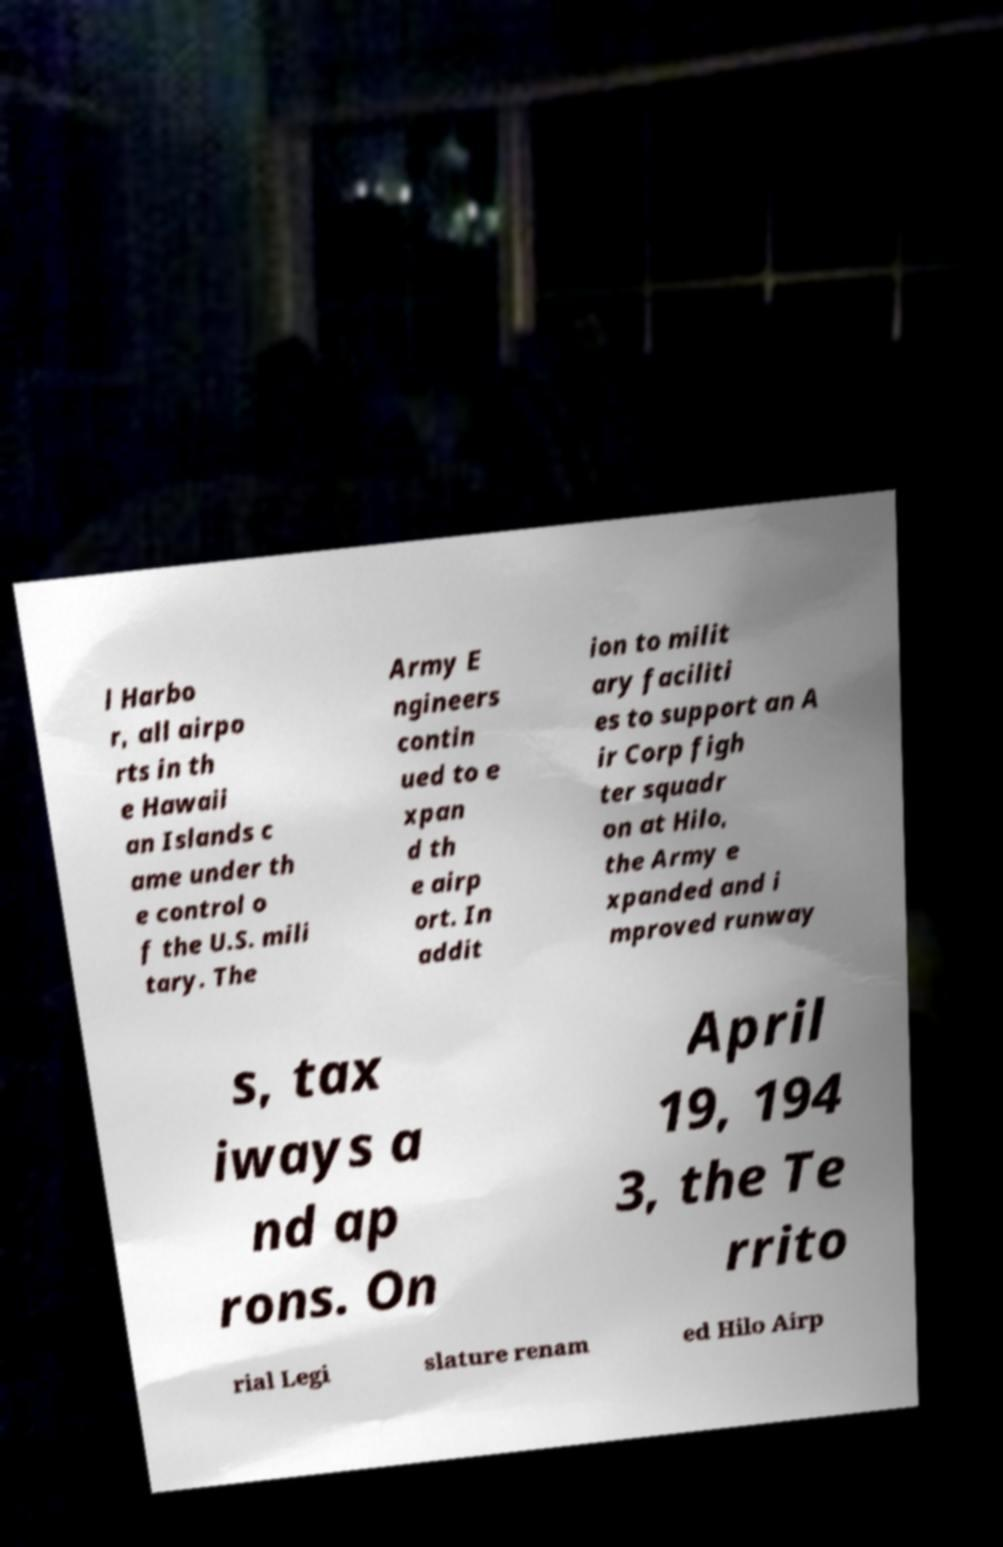Can you accurately transcribe the text from the provided image for me? l Harbo r, all airpo rts in th e Hawaii an Islands c ame under th e control o f the U.S. mili tary. The Army E ngineers contin ued to e xpan d th e airp ort. In addit ion to milit ary faciliti es to support an A ir Corp figh ter squadr on at Hilo, the Army e xpanded and i mproved runway s, tax iways a nd ap rons. On April 19, 194 3, the Te rrito rial Legi slature renam ed Hilo Airp 